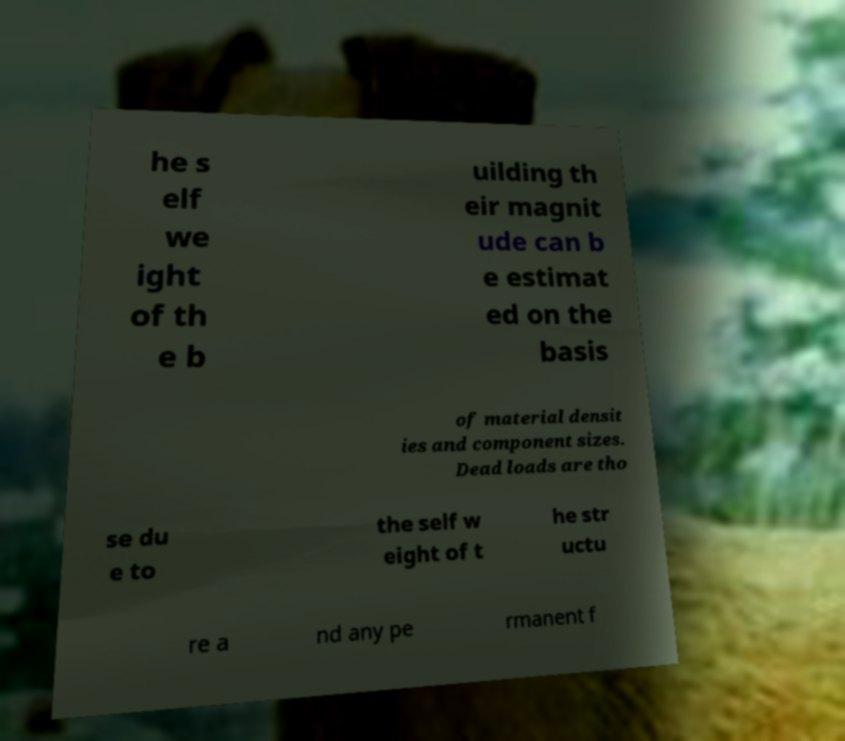For documentation purposes, I need the text within this image transcribed. Could you provide that? he s elf we ight of th e b uilding th eir magnit ude can b e estimat ed on the basis of material densit ies and component sizes. Dead loads are tho se du e to the self w eight of t he str uctu re a nd any pe rmanent f 